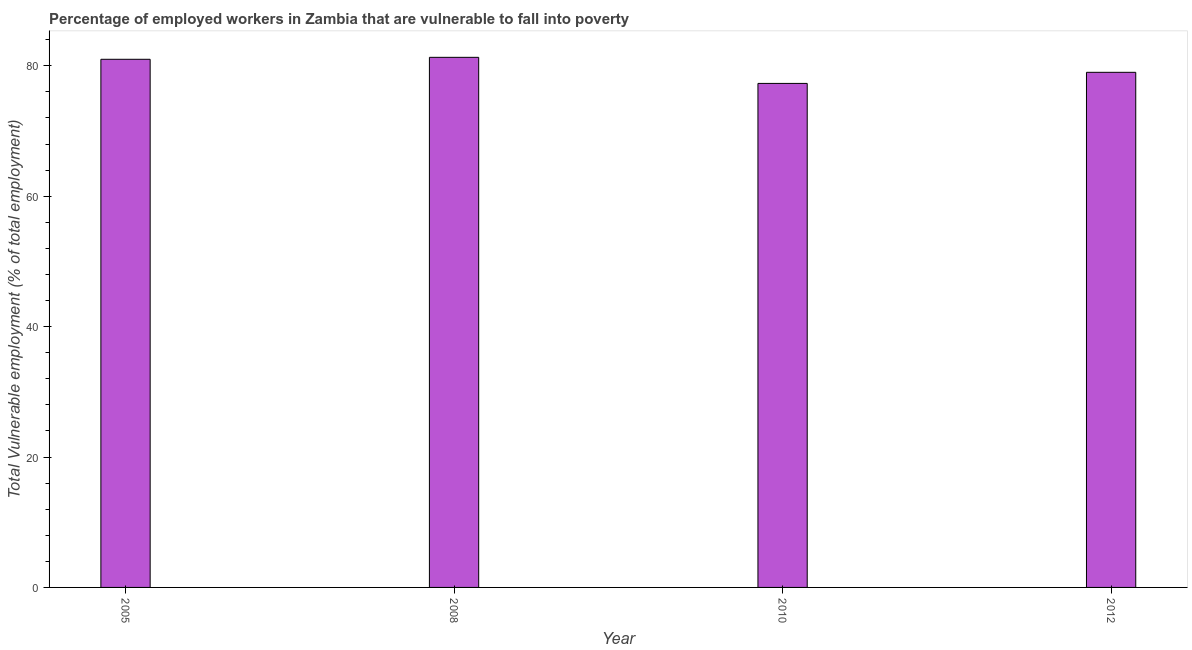Does the graph contain any zero values?
Give a very brief answer. No. What is the title of the graph?
Keep it short and to the point. Percentage of employed workers in Zambia that are vulnerable to fall into poverty. What is the label or title of the Y-axis?
Provide a succinct answer. Total Vulnerable employment (% of total employment). What is the total vulnerable employment in 2010?
Give a very brief answer. 77.3. Across all years, what is the maximum total vulnerable employment?
Offer a very short reply. 81.3. Across all years, what is the minimum total vulnerable employment?
Make the answer very short. 77.3. What is the sum of the total vulnerable employment?
Provide a succinct answer. 318.6. What is the difference between the total vulnerable employment in 2008 and 2012?
Provide a short and direct response. 2.3. What is the average total vulnerable employment per year?
Your response must be concise. 79.65. In how many years, is the total vulnerable employment greater than 8 %?
Provide a short and direct response. 4. Do a majority of the years between 2010 and 2005 (inclusive) have total vulnerable employment greater than 48 %?
Ensure brevity in your answer.  Yes. What is the ratio of the total vulnerable employment in 2008 to that in 2010?
Your answer should be compact. 1.05. Is the total vulnerable employment in 2005 less than that in 2012?
Your response must be concise. No. Is the difference between the total vulnerable employment in 2005 and 2012 greater than the difference between any two years?
Make the answer very short. No. What is the difference between the highest and the second highest total vulnerable employment?
Your response must be concise. 0.3. What is the difference between the highest and the lowest total vulnerable employment?
Ensure brevity in your answer.  4. In how many years, is the total vulnerable employment greater than the average total vulnerable employment taken over all years?
Ensure brevity in your answer.  2. Are all the bars in the graph horizontal?
Keep it short and to the point. No. What is the Total Vulnerable employment (% of total employment) of 2008?
Offer a very short reply. 81.3. What is the Total Vulnerable employment (% of total employment) in 2010?
Provide a short and direct response. 77.3. What is the Total Vulnerable employment (% of total employment) in 2012?
Your answer should be very brief. 79. What is the difference between the Total Vulnerable employment (% of total employment) in 2005 and 2010?
Offer a terse response. 3.7. What is the difference between the Total Vulnerable employment (% of total employment) in 2005 and 2012?
Provide a short and direct response. 2. What is the difference between the Total Vulnerable employment (% of total employment) in 2008 and 2012?
Offer a terse response. 2.3. What is the difference between the Total Vulnerable employment (% of total employment) in 2010 and 2012?
Provide a succinct answer. -1.7. What is the ratio of the Total Vulnerable employment (% of total employment) in 2005 to that in 2008?
Offer a very short reply. 1. What is the ratio of the Total Vulnerable employment (% of total employment) in 2005 to that in 2010?
Offer a terse response. 1.05. What is the ratio of the Total Vulnerable employment (% of total employment) in 2008 to that in 2010?
Provide a short and direct response. 1.05. What is the ratio of the Total Vulnerable employment (% of total employment) in 2010 to that in 2012?
Ensure brevity in your answer.  0.98. 